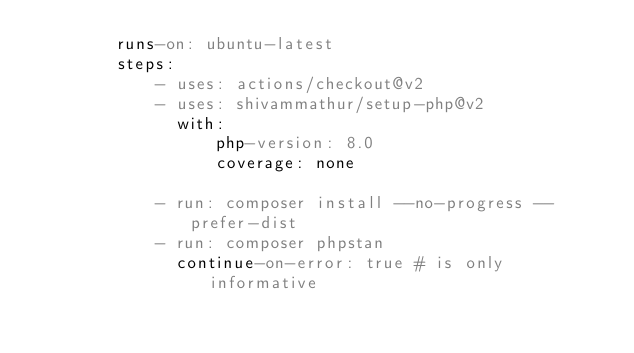Convert code to text. <code><loc_0><loc_0><loc_500><loc_500><_YAML_>        runs-on: ubuntu-latest
        steps:
            - uses: actions/checkout@v2
            - uses: shivammathur/setup-php@v2
              with:
                  php-version: 8.0
                  coverage: none

            - run: composer install --no-progress --prefer-dist
            - run: composer phpstan
              continue-on-error: true # is only informative
</code> 